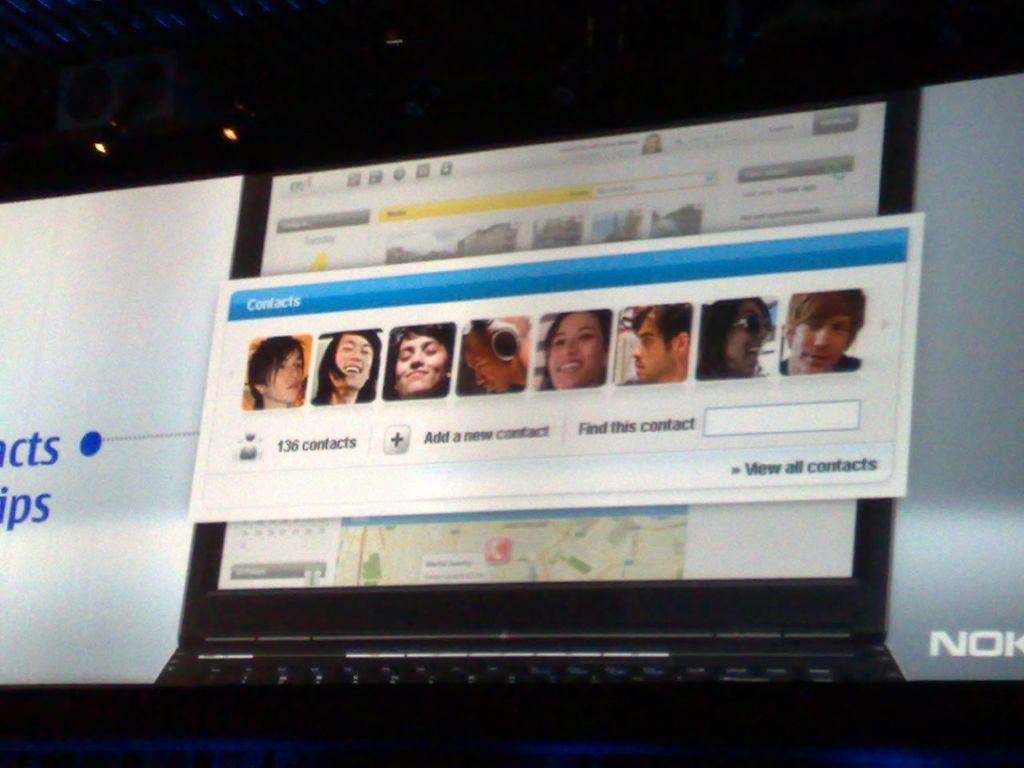<image>
Offer a succinct explanation of the picture presented. A large Nokia ad for a laptop is showing a program for contacts. 